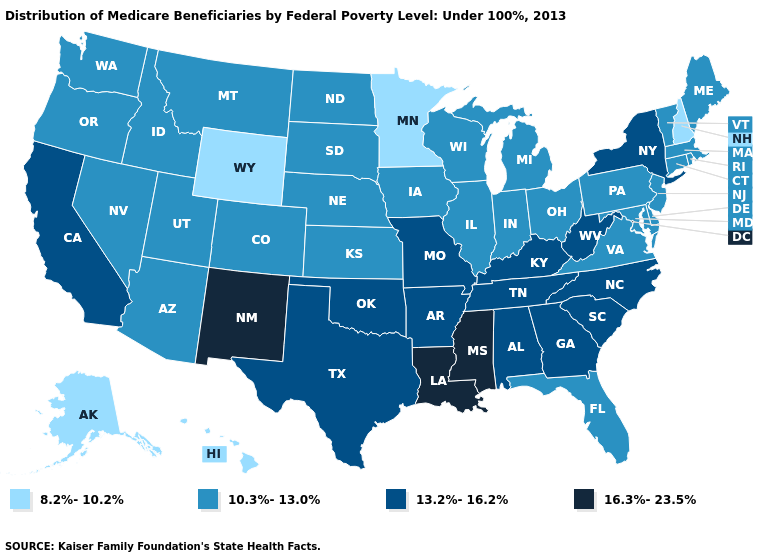What is the value of Maryland?
Give a very brief answer. 10.3%-13.0%. What is the highest value in the USA?
Short answer required. 16.3%-23.5%. Does Mississippi have the highest value in the South?
Give a very brief answer. Yes. Does Louisiana have a lower value than Florida?
Give a very brief answer. No. Name the states that have a value in the range 13.2%-16.2%?
Be succinct. Alabama, Arkansas, California, Georgia, Kentucky, Missouri, New York, North Carolina, Oklahoma, South Carolina, Tennessee, Texas, West Virginia. Does Illinois have the lowest value in the MidWest?
Give a very brief answer. No. Does the first symbol in the legend represent the smallest category?
Concise answer only. Yes. What is the value of Hawaii?
Write a very short answer. 8.2%-10.2%. Does North Carolina have the highest value in the USA?
Quick response, please. No. What is the value of West Virginia?
Keep it brief. 13.2%-16.2%. What is the value of Virginia?
Short answer required. 10.3%-13.0%. How many symbols are there in the legend?
Quick response, please. 4. What is the value of Pennsylvania?
Give a very brief answer. 10.3%-13.0%. What is the value of Illinois?
Write a very short answer. 10.3%-13.0%. Which states have the lowest value in the South?
Be succinct. Delaware, Florida, Maryland, Virginia. 